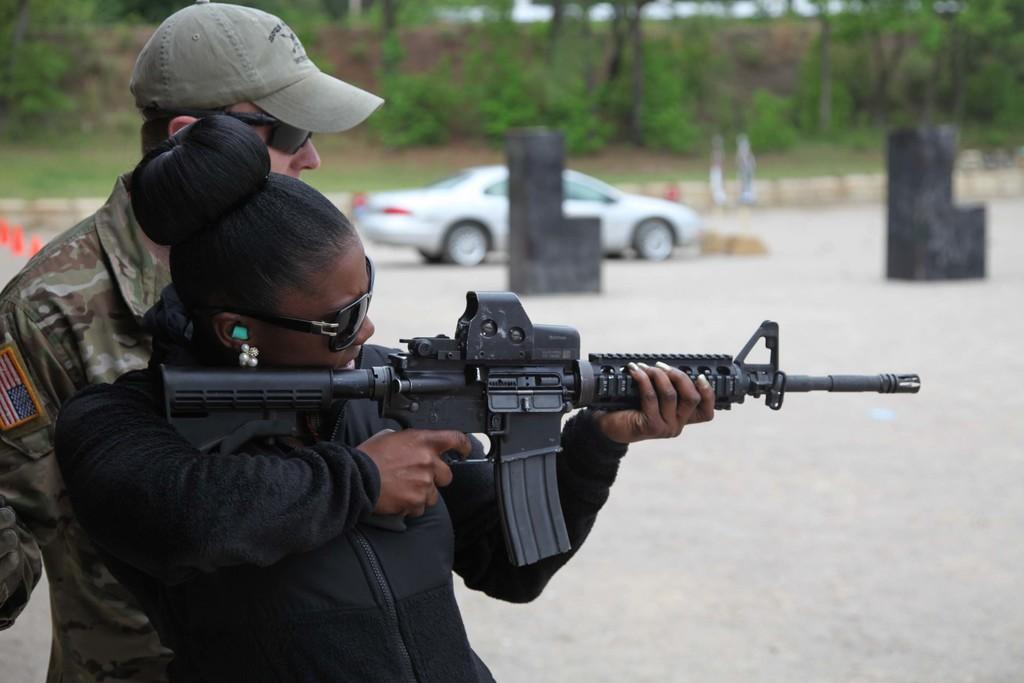What is the main subject of the image? There is a woman in the image. What is the woman holding in her hand? The woman is holding a gun in her hand. Can you describe the background of the image? There is a man, a car, trees, and a blurred background in the image. What type of pan can be seen in the woman's hand in the image? There is no pan present in the image; the woman is holding a gun. Can you recall any memories the woman might have while holding the gun in the image? The provided facts do not give any information about the woman's memories or thoughts, so it is not possible to answer this question. 